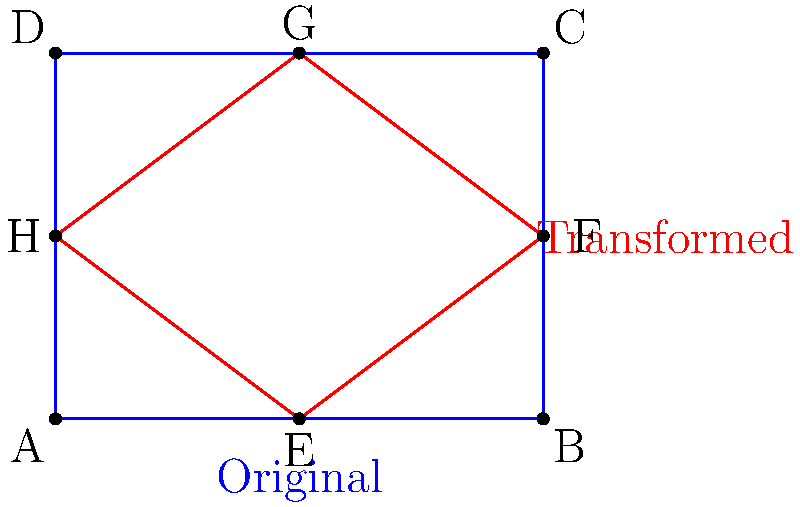The restaurant's outdoor patio area needs a redesign. The original rectangular patio (blue) has been transformed into a new shape (red) through a series of transformations. If the transformation from point A to point E is a translation of 2 units right, what composite transformation would move point B to point F? To determine the composite transformation that moves point B to point F, let's analyze the change step-by-step:

1. Translation: 
   Point B is first translated 2 units to the left (opposite of A to E translation).
   B(4,0) → (2,0)

2. Rotation:
   The point is then rotated 45° counterclockwise around the point (2,0).
   (2,0) → (2,2)

3. Dilation:
   Finally, the point is dilated by a scale factor of $\frac{\sqrt{2}}{2}$ from the center (2,0).
   (2,2) → (3,1.5)

4. Translation:
   Lastly, it's translated 1 unit right to reach F(4,1.5).
   (3,1.5) → (4,1.5)

Therefore, the composite transformation is a combination of translation, rotation, dilation, and another translation.
Answer: Translation + 45° rotation + $\frac{\sqrt{2}}{2}$ dilation + translation 